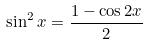<formula> <loc_0><loc_0><loc_500><loc_500>\sin ^ { 2 } x = \frac { 1 - \cos 2 x } { 2 }</formula> 